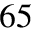<formula> <loc_0><loc_0><loc_500><loc_500>6 5</formula> 